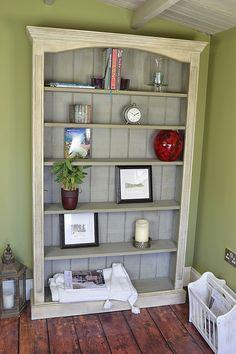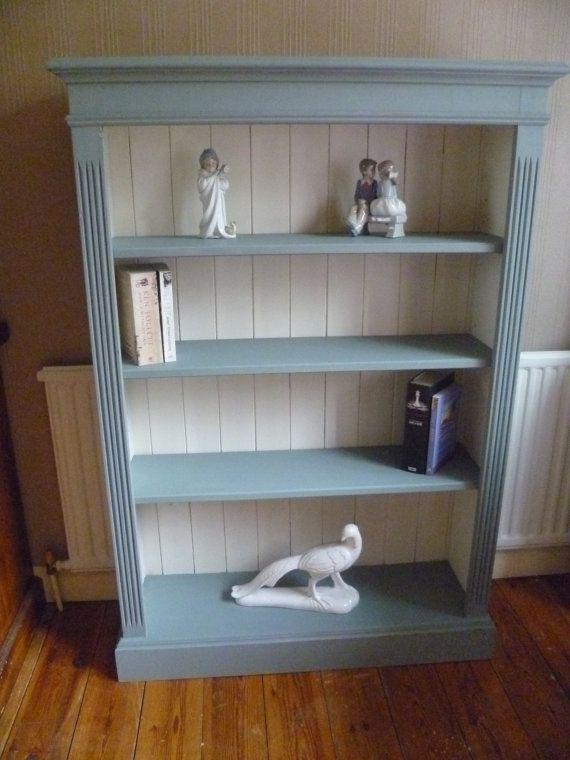The first image is the image on the left, the second image is the image on the right. Analyze the images presented: Is the assertion "One of the images contains a book shelf that is blue and white." valid? Answer yes or no. Yes. The first image is the image on the left, the second image is the image on the right. For the images shown, is this caption "An image shows a four-shelf cabinet with a blue and white color scheme and plank wood back." true? Answer yes or no. Yes. 